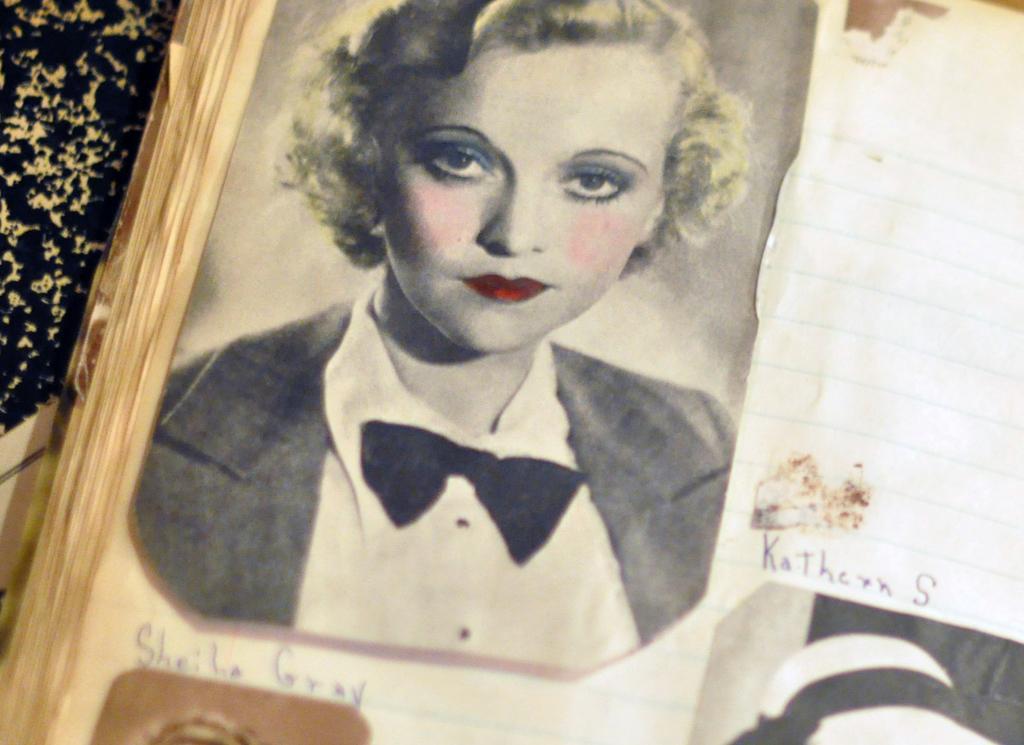Please provide a concise description of this image. In this image we can see a photo frame with some images and text, on the left side of the image there are some plants. 